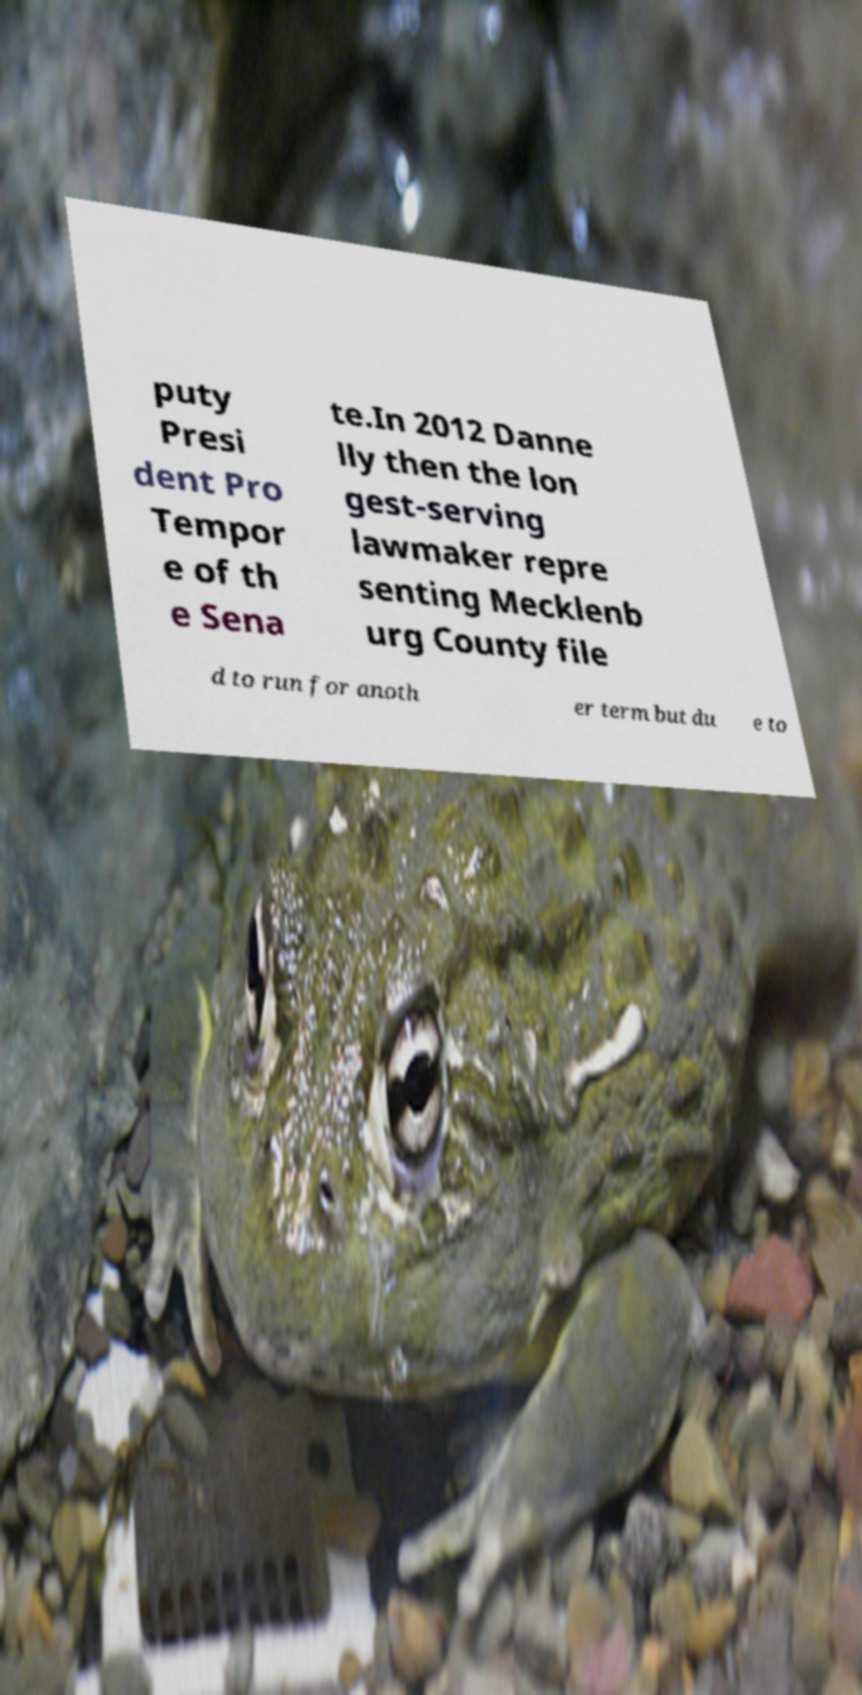I need the written content from this picture converted into text. Can you do that? puty Presi dent Pro Tempor e of th e Sena te.In 2012 Danne lly then the lon gest-serving lawmaker repre senting Mecklenb urg County file d to run for anoth er term but du e to 